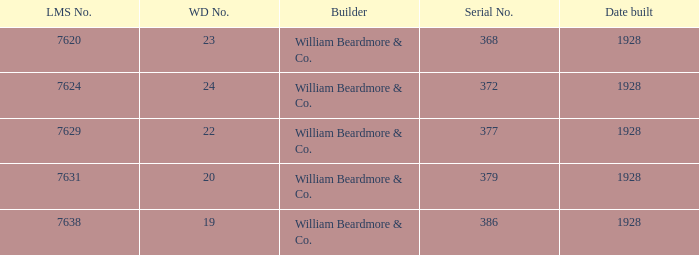Name the total number of serial number for 24 wd no 1.0. 